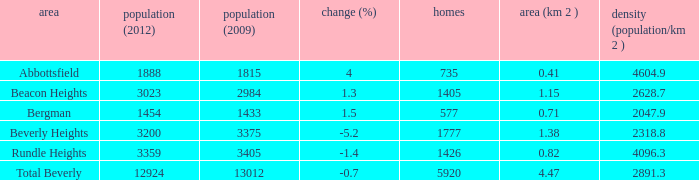How many Dwellings does Beverly Heights have that have a change percent larger than -5.2? None. 